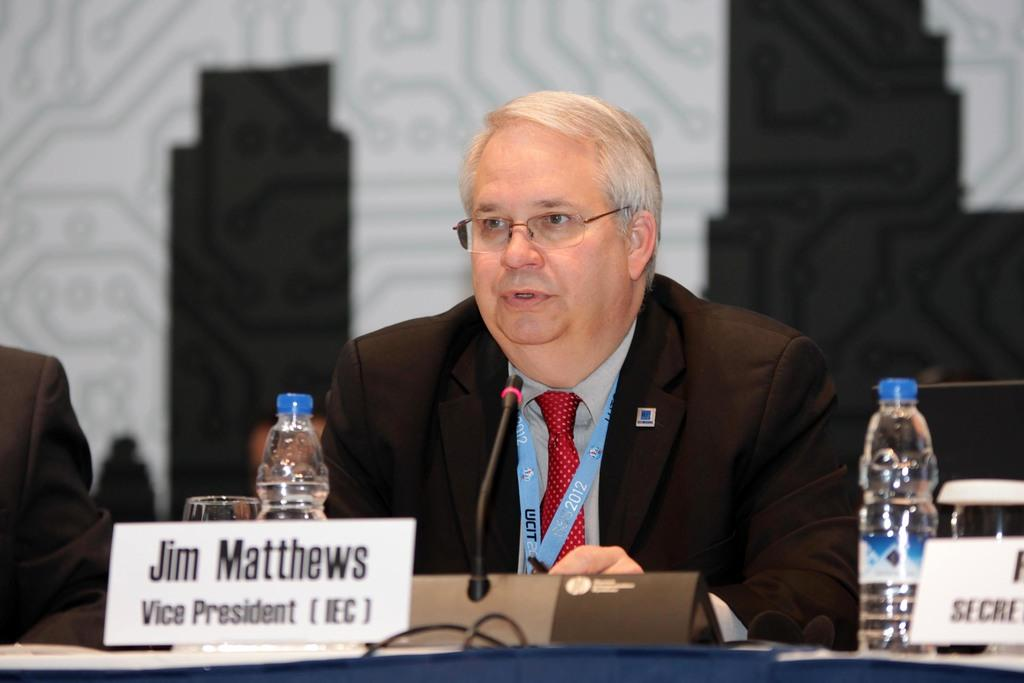What is the person in the image doing? The person is sitting and talking. What can be seen in front of the person? The person is in front of a microphone. What is on the table in front of the person? There is a bottle and a name plate on the table. What is the purpose of the microphone in the image? The microphone suggests that the person is giving a speech or presentation. Can you see any fog in the image? There is no fog present in the image. What news is the person sharing in the image? The image does not provide any information about the content of the person's speech or presentation. 